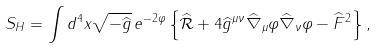Convert formula to latex. <formula><loc_0><loc_0><loc_500><loc_500>S _ { H } = \int d ^ { 4 } x \sqrt { - \widehat { g } } \, e ^ { - 2 \varphi } \left \{ \widehat { \mathcal { R } } + 4 \widehat { g } ^ { \mu \nu } \widehat { \nabla } _ { \mu } \varphi \widehat { \nabla } _ { \nu } \varphi - \widehat { F } ^ { 2 } \right \} ,</formula> 